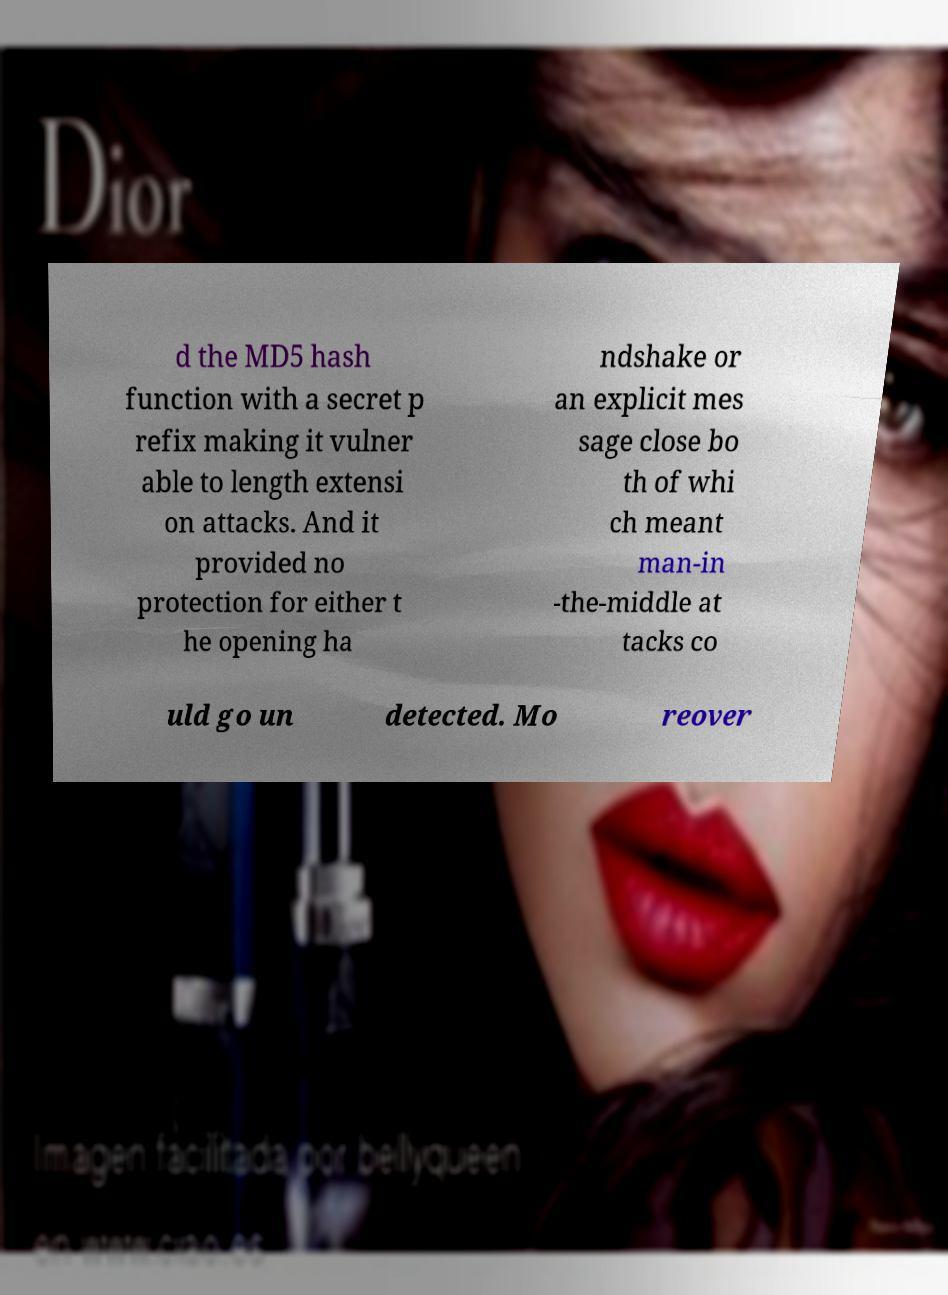For documentation purposes, I need the text within this image transcribed. Could you provide that? d the MD5 hash function with a secret p refix making it vulner able to length extensi on attacks. And it provided no protection for either t he opening ha ndshake or an explicit mes sage close bo th of whi ch meant man-in -the-middle at tacks co uld go un detected. Mo reover 